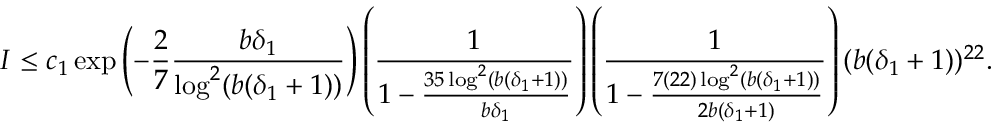<formula> <loc_0><loc_0><loc_500><loc_500>I \leq c _ { 1 } \exp \left ( - \frac { 2 } { 7 } \frac { b \delta _ { 1 } } { \log ^ { 2 } ( b ( \delta _ { 1 } + 1 ) ) } \right ) \left ( \frac { 1 } { 1 - \frac { 3 5 \log ^ { 2 } ( b ( \delta _ { 1 } + 1 ) ) } { b \delta _ { 1 } } } \right ) \left ( \frac { 1 } { 1 - \frac { 7 ( 2 2 ) \log ^ { 2 } ( b ( \delta _ { 1 } + 1 ) ) } { 2 b ( \delta _ { 1 } + 1 ) } } \right ) ( b ( \delta _ { 1 } + 1 ) ) ^ { 2 2 } .</formula> 